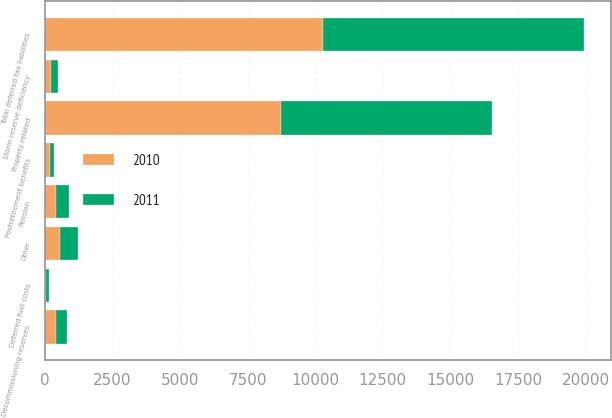Convert chart. <chart><loc_0><loc_0><loc_500><loc_500><stacked_bar_chart><ecel><fcel>Property-related<fcel>Pension<fcel>Storm reserve deficiency<fcel>Deferred fuel costs<fcel>Other<fcel>Total deferred tax liabilities<fcel>Decommissioning reserves<fcel>Postretirement benefits<nl><fcel>2010<fcel>8727<fcel>394<fcel>235<fcel>40<fcel>573<fcel>10295<fcel>406<fcel>170<nl><fcel>2011<fcel>7795<fcel>485<fcel>258<fcel>101<fcel>638<fcel>9649<fcel>393<fcel>175<nl></chart> 